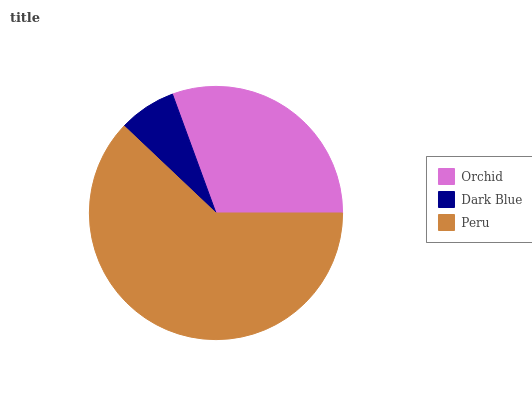Is Dark Blue the minimum?
Answer yes or no. Yes. Is Peru the maximum?
Answer yes or no. Yes. Is Peru the minimum?
Answer yes or no. No. Is Dark Blue the maximum?
Answer yes or no. No. Is Peru greater than Dark Blue?
Answer yes or no. Yes. Is Dark Blue less than Peru?
Answer yes or no. Yes. Is Dark Blue greater than Peru?
Answer yes or no. No. Is Peru less than Dark Blue?
Answer yes or no. No. Is Orchid the high median?
Answer yes or no. Yes. Is Orchid the low median?
Answer yes or no. Yes. Is Peru the high median?
Answer yes or no. No. Is Dark Blue the low median?
Answer yes or no. No. 